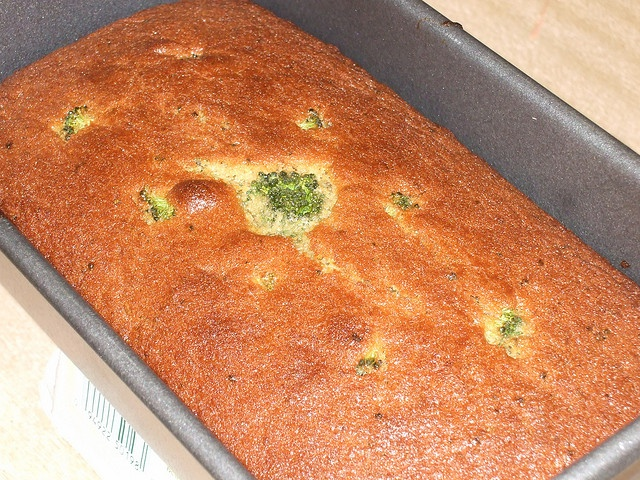Describe the objects in this image and their specific colors. I can see cake in gray, tan, red, brown, and salmon tones, broccoli in gray, olive, and khaki tones, broccoli in gray, khaki, tan, and olive tones, broccoli in gray, olive, khaki, and tan tones, and broccoli in gray, khaki, and tan tones in this image. 